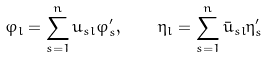<formula> <loc_0><loc_0><loc_500><loc_500>\varphi _ { l } = \sum ^ { n } _ { s = 1 } u _ { s l } \varphi ^ { \prime } _ { s } , \quad \eta _ { l } = \sum ^ { n } _ { s = 1 } \bar { u } _ { s l } \eta ^ { \prime } _ { s }</formula> 